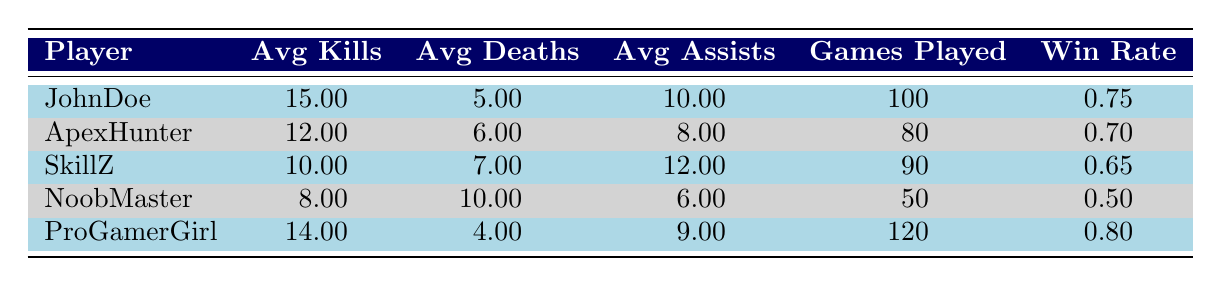What is the average number of kills for the player with the highest ranking? The player with the highest ranking is JohnDoe. According to the table, JohnDoe has an average of 15 kills.
Answer: 15 Which player has the highest average deaths? Looking at the average deaths column, NoobMaster has the highest value at 10 deaths.
Answer: NoobMaster What is the win rate of the player ranked 3rd? The table shows that SkillZ is ranked 3rd, and their win rate is 0.65.
Answer: 0.65 How many games did the player with the highest win rate play? ProGamerGirl has the highest win rate of 0.80. Referring to the games played column, ProGamerGirl played 120 games.
Answer: 120 Is there a player with an average assists score higher than 12? By checking the average assists column, only SkillZ has an average of 12, and the others are lower; thus, there is no player with more than 12 assists.
Answer: No Who has the lowest average kills and how many did they have? NoobMaster has the lowest average kills at 8.
Answer: NoobMaster, 8 What is the total average kills of all the players? To find the total average kills, we sum up the kills: 15 + 12 + 10 + 8 + 14 = 59. There are 5 players, so the average is 59/5 = 11.8.
Answer: 11.8 Which player has the highest average assists, and what is their ranking? SkillZ has the highest average assists at 12 and is ranked 3rd.
Answer: SkillZ, 3 If JohnDoe's average deaths had been 8 instead of 5, would he still have the highest win rate? JohnDoe's win rate is currently 0.75. Changing his average deaths to 8 does not directly affect win rate; thus we need to check if any other player has a win rate higher than 0.75. ProGamerGirl is at 0.80, so JohnDoe would not have the highest anymore.
Answer: No What is the difference between the average kill count of JohnDoe and NoobMaster? JohnDoe's average kills are 15 and NoobMaster's are 8. The difference is 15 - 8 = 7.
Answer: 7 